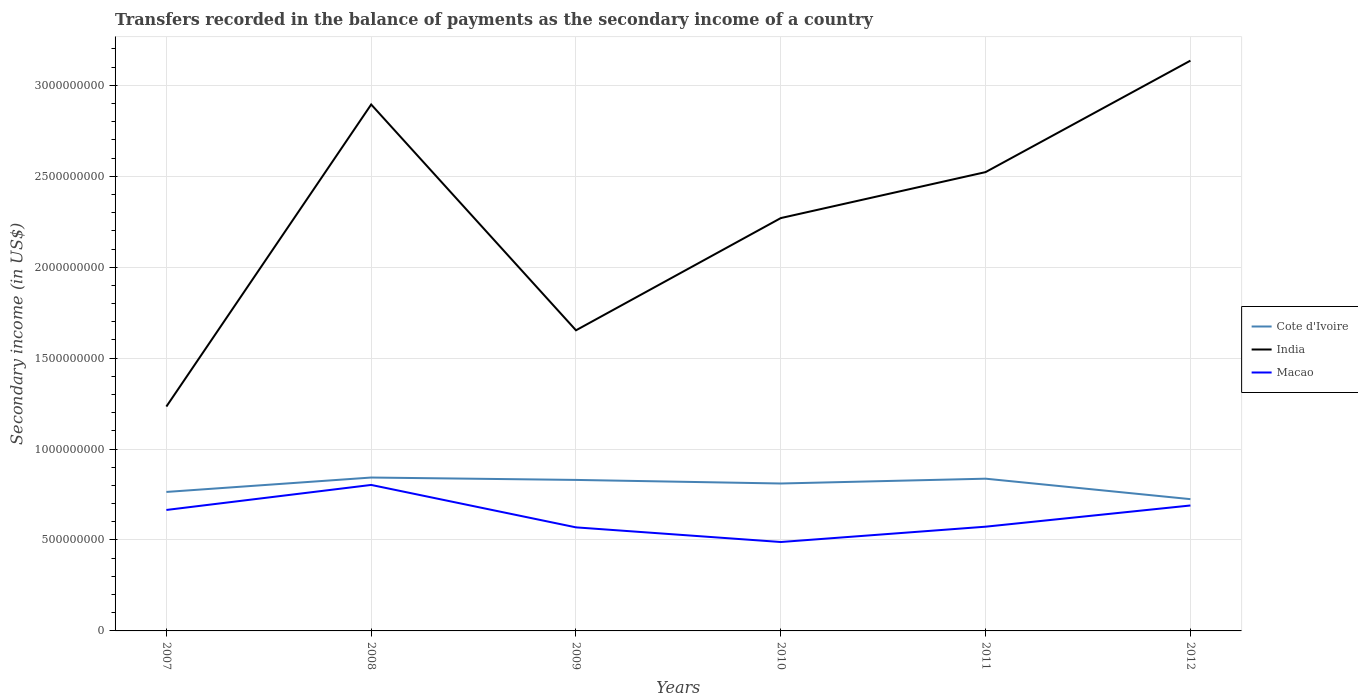Does the line corresponding to Macao intersect with the line corresponding to Cote d'Ivoire?
Provide a succinct answer. No. Is the number of lines equal to the number of legend labels?
Offer a terse response. Yes. Across all years, what is the maximum secondary income of in Cote d'Ivoire?
Your response must be concise. 7.25e+08. In which year was the secondary income of in India maximum?
Your answer should be very brief. 2007. What is the total secondary income of in Macao in the graph?
Provide a short and direct response. 3.14e+08. What is the difference between the highest and the second highest secondary income of in Cote d'Ivoire?
Offer a terse response. 1.19e+08. Is the secondary income of in Cote d'Ivoire strictly greater than the secondary income of in India over the years?
Offer a terse response. Yes. How many lines are there?
Make the answer very short. 3. How many years are there in the graph?
Ensure brevity in your answer.  6. What is the difference between two consecutive major ticks on the Y-axis?
Give a very brief answer. 5.00e+08. Does the graph contain any zero values?
Your answer should be very brief. No. Does the graph contain grids?
Your answer should be compact. Yes. Where does the legend appear in the graph?
Provide a succinct answer. Center right. How many legend labels are there?
Offer a very short reply. 3. How are the legend labels stacked?
Your answer should be very brief. Vertical. What is the title of the graph?
Your answer should be very brief. Transfers recorded in the balance of payments as the secondary income of a country. Does "Spain" appear as one of the legend labels in the graph?
Provide a succinct answer. No. What is the label or title of the Y-axis?
Keep it short and to the point. Secondary income (in US$). What is the Secondary income (in US$) of Cote d'Ivoire in 2007?
Provide a short and direct response. 7.64e+08. What is the Secondary income (in US$) in India in 2007?
Keep it short and to the point. 1.23e+09. What is the Secondary income (in US$) in Macao in 2007?
Make the answer very short. 6.65e+08. What is the Secondary income (in US$) in Cote d'Ivoire in 2008?
Offer a terse response. 8.43e+08. What is the Secondary income (in US$) of India in 2008?
Offer a very short reply. 2.89e+09. What is the Secondary income (in US$) of Macao in 2008?
Offer a very short reply. 8.03e+08. What is the Secondary income (in US$) of Cote d'Ivoire in 2009?
Keep it short and to the point. 8.30e+08. What is the Secondary income (in US$) of India in 2009?
Provide a succinct answer. 1.65e+09. What is the Secondary income (in US$) in Macao in 2009?
Make the answer very short. 5.69e+08. What is the Secondary income (in US$) of Cote d'Ivoire in 2010?
Ensure brevity in your answer.  8.11e+08. What is the Secondary income (in US$) in India in 2010?
Ensure brevity in your answer.  2.27e+09. What is the Secondary income (in US$) of Macao in 2010?
Your answer should be very brief. 4.89e+08. What is the Secondary income (in US$) of Cote d'Ivoire in 2011?
Your response must be concise. 8.37e+08. What is the Secondary income (in US$) in India in 2011?
Keep it short and to the point. 2.52e+09. What is the Secondary income (in US$) in Macao in 2011?
Your answer should be very brief. 5.73e+08. What is the Secondary income (in US$) of Cote d'Ivoire in 2012?
Provide a succinct answer. 7.25e+08. What is the Secondary income (in US$) in India in 2012?
Provide a succinct answer. 3.14e+09. What is the Secondary income (in US$) of Macao in 2012?
Give a very brief answer. 6.90e+08. Across all years, what is the maximum Secondary income (in US$) of Cote d'Ivoire?
Your answer should be very brief. 8.43e+08. Across all years, what is the maximum Secondary income (in US$) in India?
Your answer should be very brief. 3.14e+09. Across all years, what is the maximum Secondary income (in US$) of Macao?
Offer a very short reply. 8.03e+08. Across all years, what is the minimum Secondary income (in US$) of Cote d'Ivoire?
Offer a very short reply. 7.25e+08. Across all years, what is the minimum Secondary income (in US$) of India?
Keep it short and to the point. 1.23e+09. Across all years, what is the minimum Secondary income (in US$) in Macao?
Keep it short and to the point. 4.89e+08. What is the total Secondary income (in US$) of Cote d'Ivoire in the graph?
Your response must be concise. 4.81e+09. What is the total Secondary income (in US$) of India in the graph?
Your answer should be compact. 1.37e+1. What is the total Secondary income (in US$) of Macao in the graph?
Ensure brevity in your answer.  3.79e+09. What is the difference between the Secondary income (in US$) of Cote d'Ivoire in 2007 and that in 2008?
Provide a short and direct response. -7.92e+07. What is the difference between the Secondary income (in US$) in India in 2007 and that in 2008?
Your response must be concise. -1.66e+09. What is the difference between the Secondary income (in US$) in Macao in 2007 and that in 2008?
Your answer should be compact. -1.38e+08. What is the difference between the Secondary income (in US$) in Cote d'Ivoire in 2007 and that in 2009?
Provide a short and direct response. -6.61e+07. What is the difference between the Secondary income (in US$) in India in 2007 and that in 2009?
Give a very brief answer. -4.19e+08. What is the difference between the Secondary income (in US$) of Macao in 2007 and that in 2009?
Ensure brevity in your answer.  9.57e+07. What is the difference between the Secondary income (in US$) in Cote d'Ivoire in 2007 and that in 2010?
Provide a succinct answer. -4.64e+07. What is the difference between the Secondary income (in US$) in India in 2007 and that in 2010?
Offer a terse response. -1.04e+09. What is the difference between the Secondary income (in US$) in Macao in 2007 and that in 2010?
Offer a very short reply. 1.76e+08. What is the difference between the Secondary income (in US$) of Cote d'Ivoire in 2007 and that in 2011?
Make the answer very short. -7.29e+07. What is the difference between the Secondary income (in US$) of India in 2007 and that in 2011?
Offer a terse response. -1.29e+09. What is the difference between the Secondary income (in US$) of Macao in 2007 and that in 2011?
Your response must be concise. 9.20e+07. What is the difference between the Secondary income (in US$) of Cote d'Ivoire in 2007 and that in 2012?
Your response must be concise. 3.96e+07. What is the difference between the Secondary income (in US$) of India in 2007 and that in 2012?
Offer a terse response. -1.90e+09. What is the difference between the Secondary income (in US$) of Macao in 2007 and that in 2012?
Keep it short and to the point. -2.46e+07. What is the difference between the Secondary income (in US$) of Cote d'Ivoire in 2008 and that in 2009?
Provide a short and direct response. 1.31e+07. What is the difference between the Secondary income (in US$) in India in 2008 and that in 2009?
Offer a very short reply. 1.24e+09. What is the difference between the Secondary income (in US$) of Macao in 2008 and that in 2009?
Keep it short and to the point. 2.33e+08. What is the difference between the Secondary income (in US$) of Cote d'Ivoire in 2008 and that in 2010?
Your answer should be very brief. 3.28e+07. What is the difference between the Secondary income (in US$) in India in 2008 and that in 2010?
Your answer should be very brief. 6.25e+08. What is the difference between the Secondary income (in US$) in Macao in 2008 and that in 2010?
Keep it short and to the point. 3.14e+08. What is the difference between the Secondary income (in US$) of Cote d'Ivoire in 2008 and that in 2011?
Offer a terse response. 6.31e+06. What is the difference between the Secondary income (in US$) in India in 2008 and that in 2011?
Provide a short and direct response. 3.72e+08. What is the difference between the Secondary income (in US$) of Macao in 2008 and that in 2011?
Offer a terse response. 2.30e+08. What is the difference between the Secondary income (in US$) of Cote d'Ivoire in 2008 and that in 2012?
Provide a succinct answer. 1.19e+08. What is the difference between the Secondary income (in US$) of India in 2008 and that in 2012?
Keep it short and to the point. -2.41e+08. What is the difference between the Secondary income (in US$) in Macao in 2008 and that in 2012?
Offer a terse response. 1.13e+08. What is the difference between the Secondary income (in US$) of Cote d'Ivoire in 2009 and that in 2010?
Make the answer very short. 1.97e+07. What is the difference between the Secondary income (in US$) of India in 2009 and that in 2010?
Offer a terse response. -6.17e+08. What is the difference between the Secondary income (in US$) in Macao in 2009 and that in 2010?
Give a very brief answer. 8.05e+07. What is the difference between the Secondary income (in US$) in Cote d'Ivoire in 2009 and that in 2011?
Provide a succinct answer. -6.79e+06. What is the difference between the Secondary income (in US$) of India in 2009 and that in 2011?
Offer a terse response. -8.70e+08. What is the difference between the Secondary income (in US$) in Macao in 2009 and that in 2011?
Your answer should be compact. -3.74e+06. What is the difference between the Secondary income (in US$) in Cote d'Ivoire in 2009 and that in 2012?
Offer a terse response. 1.06e+08. What is the difference between the Secondary income (in US$) of India in 2009 and that in 2012?
Make the answer very short. -1.48e+09. What is the difference between the Secondary income (in US$) in Macao in 2009 and that in 2012?
Give a very brief answer. -1.20e+08. What is the difference between the Secondary income (in US$) in Cote d'Ivoire in 2010 and that in 2011?
Ensure brevity in your answer.  -2.65e+07. What is the difference between the Secondary income (in US$) in India in 2010 and that in 2011?
Your answer should be compact. -2.53e+08. What is the difference between the Secondary income (in US$) in Macao in 2010 and that in 2011?
Keep it short and to the point. -8.42e+07. What is the difference between the Secondary income (in US$) in Cote d'Ivoire in 2010 and that in 2012?
Offer a very short reply. 8.60e+07. What is the difference between the Secondary income (in US$) of India in 2010 and that in 2012?
Offer a terse response. -8.66e+08. What is the difference between the Secondary income (in US$) of Macao in 2010 and that in 2012?
Provide a succinct answer. -2.01e+08. What is the difference between the Secondary income (in US$) in Cote d'Ivoire in 2011 and that in 2012?
Offer a terse response. 1.13e+08. What is the difference between the Secondary income (in US$) of India in 2011 and that in 2012?
Offer a terse response. -6.13e+08. What is the difference between the Secondary income (in US$) of Macao in 2011 and that in 2012?
Your answer should be very brief. -1.17e+08. What is the difference between the Secondary income (in US$) of Cote d'Ivoire in 2007 and the Secondary income (in US$) of India in 2008?
Provide a short and direct response. -2.13e+09. What is the difference between the Secondary income (in US$) in Cote d'Ivoire in 2007 and the Secondary income (in US$) in Macao in 2008?
Provide a short and direct response. -3.85e+07. What is the difference between the Secondary income (in US$) of India in 2007 and the Secondary income (in US$) of Macao in 2008?
Provide a succinct answer. 4.31e+08. What is the difference between the Secondary income (in US$) in Cote d'Ivoire in 2007 and the Secondary income (in US$) in India in 2009?
Offer a very short reply. -8.89e+08. What is the difference between the Secondary income (in US$) in Cote d'Ivoire in 2007 and the Secondary income (in US$) in Macao in 2009?
Make the answer very short. 1.95e+08. What is the difference between the Secondary income (in US$) of India in 2007 and the Secondary income (in US$) of Macao in 2009?
Make the answer very short. 6.64e+08. What is the difference between the Secondary income (in US$) of Cote d'Ivoire in 2007 and the Secondary income (in US$) of India in 2010?
Ensure brevity in your answer.  -1.51e+09. What is the difference between the Secondary income (in US$) in Cote d'Ivoire in 2007 and the Secondary income (in US$) in Macao in 2010?
Your response must be concise. 2.75e+08. What is the difference between the Secondary income (in US$) in India in 2007 and the Secondary income (in US$) in Macao in 2010?
Keep it short and to the point. 7.45e+08. What is the difference between the Secondary income (in US$) in Cote d'Ivoire in 2007 and the Secondary income (in US$) in India in 2011?
Give a very brief answer. -1.76e+09. What is the difference between the Secondary income (in US$) in Cote d'Ivoire in 2007 and the Secondary income (in US$) in Macao in 2011?
Ensure brevity in your answer.  1.91e+08. What is the difference between the Secondary income (in US$) of India in 2007 and the Secondary income (in US$) of Macao in 2011?
Your answer should be very brief. 6.61e+08. What is the difference between the Secondary income (in US$) of Cote d'Ivoire in 2007 and the Secondary income (in US$) of India in 2012?
Your response must be concise. -2.37e+09. What is the difference between the Secondary income (in US$) of Cote d'Ivoire in 2007 and the Secondary income (in US$) of Macao in 2012?
Make the answer very short. 7.45e+07. What is the difference between the Secondary income (in US$) of India in 2007 and the Secondary income (in US$) of Macao in 2012?
Your answer should be compact. 5.44e+08. What is the difference between the Secondary income (in US$) in Cote d'Ivoire in 2008 and the Secondary income (in US$) in India in 2009?
Give a very brief answer. -8.10e+08. What is the difference between the Secondary income (in US$) of Cote d'Ivoire in 2008 and the Secondary income (in US$) of Macao in 2009?
Keep it short and to the point. 2.74e+08. What is the difference between the Secondary income (in US$) in India in 2008 and the Secondary income (in US$) in Macao in 2009?
Your answer should be compact. 2.33e+09. What is the difference between the Secondary income (in US$) of Cote d'Ivoire in 2008 and the Secondary income (in US$) of India in 2010?
Give a very brief answer. -1.43e+09. What is the difference between the Secondary income (in US$) of Cote d'Ivoire in 2008 and the Secondary income (in US$) of Macao in 2010?
Your response must be concise. 3.55e+08. What is the difference between the Secondary income (in US$) of India in 2008 and the Secondary income (in US$) of Macao in 2010?
Provide a succinct answer. 2.41e+09. What is the difference between the Secondary income (in US$) in Cote d'Ivoire in 2008 and the Secondary income (in US$) in India in 2011?
Offer a terse response. -1.68e+09. What is the difference between the Secondary income (in US$) of Cote d'Ivoire in 2008 and the Secondary income (in US$) of Macao in 2011?
Your response must be concise. 2.70e+08. What is the difference between the Secondary income (in US$) of India in 2008 and the Secondary income (in US$) of Macao in 2011?
Provide a succinct answer. 2.32e+09. What is the difference between the Secondary income (in US$) of Cote d'Ivoire in 2008 and the Secondary income (in US$) of India in 2012?
Your answer should be very brief. -2.29e+09. What is the difference between the Secondary income (in US$) in Cote d'Ivoire in 2008 and the Secondary income (in US$) in Macao in 2012?
Ensure brevity in your answer.  1.54e+08. What is the difference between the Secondary income (in US$) of India in 2008 and the Secondary income (in US$) of Macao in 2012?
Your response must be concise. 2.20e+09. What is the difference between the Secondary income (in US$) of Cote d'Ivoire in 2009 and the Secondary income (in US$) of India in 2010?
Your response must be concise. -1.44e+09. What is the difference between the Secondary income (in US$) of Cote d'Ivoire in 2009 and the Secondary income (in US$) of Macao in 2010?
Your answer should be compact. 3.41e+08. What is the difference between the Secondary income (in US$) of India in 2009 and the Secondary income (in US$) of Macao in 2010?
Your response must be concise. 1.16e+09. What is the difference between the Secondary income (in US$) in Cote d'Ivoire in 2009 and the Secondary income (in US$) in India in 2011?
Your answer should be very brief. -1.69e+09. What is the difference between the Secondary income (in US$) of Cote d'Ivoire in 2009 and the Secondary income (in US$) of Macao in 2011?
Your answer should be very brief. 2.57e+08. What is the difference between the Secondary income (in US$) of India in 2009 and the Secondary income (in US$) of Macao in 2011?
Offer a very short reply. 1.08e+09. What is the difference between the Secondary income (in US$) in Cote d'Ivoire in 2009 and the Secondary income (in US$) in India in 2012?
Your answer should be compact. -2.31e+09. What is the difference between the Secondary income (in US$) in Cote d'Ivoire in 2009 and the Secondary income (in US$) in Macao in 2012?
Your answer should be compact. 1.41e+08. What is the difference between the Secondary income (in US$) of India in 2009 and the Secondary income (in US$) of Macao in 2012?
Your response must be concise. 9.63e+08. What is the difference between the Secondary income (in US$) of Cote d'Ivoire in 2010 and the Secondary income (in US$) of India in 2011?
Make the answer very short. -1.71e+09. What is the difference between the Secondary income (in US$) of Cote d'Ivoire in 2010 and the Secondary income (in US$) of Macao in 2011?
Provide a succinct answer. 2.37e+08. What is the difference between the Secondary income (in US$) in India in 2010 and the Secondary income (in US$) in Macao in 2011?
Your response must be concise. 1.70e+09. What is the difference between the Secondary income (in US$) in Cote d'Ivoire in 2010 and the Secondary income (in US$) in India in 2012?
Provide a short and direct response. -2.33e+09. What is the difference between the Secondary income (in US$) of Cote d'Ivoire in 2010 and the Secondary income (in US$) of Macao in 2012?
Make the answer very short. 1.21e+08. What is the difference between the Secondary income (in US$) in India in 2010 and the Secondary income (in US$) in Macao in 2012?
Keep it short and to the point. 1.58e+09. What is the difference between the Secondary income (in US$) in Cote d'Ivoire in 2011 and the Secondary income (in US$) in India in 2012?
Make the answer very short. -2.30e+09. What is the difference between the Secondary income (in US$) of Cote d'Ivoire in 2011 and the Secondary income (in US$) of Macao in 2012?
Keep it short and to the point. 1.47e+08. What is the difference between the Secondary income (in US$) of India in 2011 and the Secondary income (in US$) of Macao in 2012?
Make the answer very short. 1.83e+09. What is the average Secondary income (in US$) of Cote d'Ivoire per year?
Keep it short and to the point. 8.02e+08. What is the average Secondary income (in US$) of India per year?
Your answer should be very brief. 2.29e+09. What is the average Secondary income (in US$) of Macao per year?
Make the answer very short. 6.31e+08. In the year 2007, what is the difference between the Secondary income (in US$) in Cote d'Ivoire and Secondary income (in US$) in India?
Keep it short and to the point. -4.70e+08. In the year 2007, what is the difference between the Secondary income (in US$) of Cote d'Ivoire and Secondary income (in US$) of Macao?
Keep it short and to the point. 9.91e+07. In the year 2007, what is the difference between the Secondary income (in US$) of India and Secondary income (in US$) of Macao?
Make the answer very short. 5.69e+08. In the year 2008, what is the difference between the Secondary income (in US$) of Cote d'Ivoire and Secondary income (in US$) of India?
Make the answer very short. -2.05e+09. In the year 2008, what is the difference between the Secondary income (in US$) of Cote d'Ivoire and Secondary income (in US$) of Macao?
Your answer should be very brief. 4.07e+07. In the year 2008, what is the difference between the Secondary income (in US$) of India and Secondary income (in US$) of Macao?
Give a very brief answer. 2.09e+09. In the year 2009, what is the difference between the Secondary income (in US$) of Cote d'Ivoire and Secondary income (in US$) of India?
Offer a terse response. -8.23e+08. In the year 2009, what is the difference between the Secondary income (in US$) in Cote d'Ivoire and Secondary income (in US$) in Macao?
Keep it short and to the point. 2.61e+08. In the year 2009, what is the difference between the Secondary income (in US$) in India and Secondary income (in US$) in Macao?
Give a very brief answer. 1.08e+09. In the year 2010, what is the difference between the Secondary income (in US$) in Cote d'Ivoire and Secondary income (in US$) in India?
Your answer should be very brief. -1.46e+09. In the year 2010, what is the difference between the Secondary income (in US$) in Cote d'Ivoire and Secondary income (in US$) in Macao?
Your response must be concise. 3.22e+08. In the year 2010, what is the difference between the Secondary income (in US$) in India and Secondary income (in US$) in Macao?
Provide a succinct answer. 1.78e+09. In the year 2011, what is the difference between the Secondary income (in US$) of Cote d'Ivoire and Secondary income (in US$) of India?
Offer a terse response. -1.69e+09. In the year 2011, what is the difference between the Secondary income (in US$) of Cote d'Ivoire and Secondary income (in US$) of Macao?
Offer a terse response. 2.64e+08. In the year 2011, what is the difference between the Secondary income (in US$) of India and Secondary income (in US$) of Macao?
Offer a very short reply. 1.95e+09. In the year 2012, what is the difference between the Secondary income (in US$) of Cote d'Ivoire and Secondary income (in US$) of India?
Provide a short and direct response. -2.41e+09. In the year 2012, what is the difference between the Secondary income (in US$) of Cote d'Ivoire and Secondary income (in US$) of Macao?
Your answer should be compact. 3.48e+07. In the year 2012, what is the difference between the Secondary income (in US$) of India and Secondary income (in US$) of Macao?
Your answer should be very brief. 2.45e+09. What is the ratio of the Secondary income (in US$) in Cote d'Ivoire in 2007 to that in 2008?
Offer a terse response. 0.91. What is the ratio of the Secondary income (in US$) of India in 2007 to that in 2008?
Your response must be concise. 0.43. What is the ratio of the Secondary income (in US$) in Macao in 2007 to that in 2008?
Your answer should be very brief. 0.83. What is the ratio of the Secondary income (in US$) of Cote d'Ivoire in 2007 to that in 2009?
Your answer should be compact. 0.92. What is the ratio of the Secondary income (in US$) of India in 2007 to that in 2009?
Your answer should be very brief. 0.75. What is the ratio of the Secondary income (in US$) in Macao in 2007 to that in 2009?
Offer a terse response. 1.17. What is the ratio of the Secondary income (in US$) in Cote d'Ivoire in 2007 to that in 2010?
Keep it short and to the point. 0.94. What is the ratio of the Secondary income (in US$) of India in 2007 to that in 2010?
Ensure brevity in your answer.  0.54. What is the ratio of the Secondary income (in US$) in Macao in 2007 to that in 2010?
Keep it short and to the point. 1.36. What is the ratio of the Secondary income (in US$) in Cote d'Ivoire in 2007 to that in 2011?
Provide a succinct answer. 0.91. What is the ratio of the Secondary income (in US$) in India in 2007 to that in 2011?
Your answer should be compact. 0.49. What is the ratio of the Secondary income (in US$) in Macao in 2007 to that in 2011?
Offer a terse response. 1.16. What is the ratio of the Secondary income (in US$) of Cote d'Ivoire in 2007 to that in 2012?
Ensure brevity in your answer.  1.05. What is the ratio of the Secondary income (in US$) of India in 2007 to that in 2012?
Ensure brevity in your answer.  0.39. What is the ratio of the Secondary income (in US$) in Cote d'Ivoire in 2008 to that in 2009?
Offer a very short reply. 1.02. What is the ratio of the Secondary income (in US$) of India in 2008 to that in 2009?
Your answer should be compact. 1.75. What is the ratio of the Secondary income (in US$) of Macao in 2008 to that in 2009?
Your response must be concise. 1.41. What is the ratio of the Secondary income (in US$) of Cote d'Ivoire in 2008 to that in 2010?
Keep it short and to the point. 1.04. What is the ratio of the Secondary income (in US$) of India in 2008 to that in 2010?
Provide a short and direct response. 1.28. What is the ratio of the Secondary income (in US$) of Macao in 2008 to that in 2010?
Offer a terse response. 1.64. What is the ratio of the Secondary income (in US$) of Cote d'Ivoire in 2008 to that in 2011?
Give a very brief answer. 1.01. What is the ratio of the Secondary income (in US$) of India in 2008 to that in 2011?
Offer a terse response. 1.15. What is the ratio of the Secondary income (in US$) of Macao in 2008 to that in 2011?
Ensure brevity in your answer.  1.4. What is the ratio of the Secondary income (in US$) of Cote d'Ivoire in 2008 to that in 2012?
Your answer should be very brief. 1.16. What is the ratio of the Secondary income (in US$) of India in 2008 to that in 2012?
Offer a very short reply. 0.92. What is the ratio of the Secondary income (in US$) of Macao in 2008 to that in 2012?
Give a very brief answer. 1.16. What is the ratio of the Secondary income (in US$) of Cote d'Ivoire in 2009 to that in 2010?
Offer a terse response. 1.02. What is the ratio of the Secondary income (in US$) in India in 2009 to that in 2010?
Your response must be concise. 0.73. What is the ratio of the Secondary income (in US$) in Macao in 2009 to that in 2010?
Keep it short and to the point. 1.16. What is the ratio of the Secondary income (in US$) in India in 2009 to that in 2011?
Your answer should be compact. 0.66. What is the ratio of the Secondary income (in US$) of Macao in 2009 to that in 2011?
Your answer should be very brief. 0.99. What is the ratio of the Secondary income (in US$) of Cote d'Ivoire in 2009 to that in 2012?
Offer a very short reply. 1.15. What is the ratio of the Secondary income (in US$) in India in 2009 to that in 2012?
Keep it short and to the point. 0.53. What is the ratio of the Secondary income (in US$) in Macao in 2009 to that in 2012?
Make the answer very short. 0.83. What is the ratio of the Secondary income (in US$) in Cote d'Ivoire in 2010 to that in 2011?
Offer a terse response. 0.97. What is the ratio of the Secondary income (in US$) in India in 2010 to that in 2011?
Keep it short and to the point. 0.9. What is the ratio of the Secondary income (in US$) in Macao in 2010 to that in 2011?
Your response must be concise. 0.85. What is the ratio of the Secondary income (in US$) in Cote d'Ivoire in 2010 to that in 2012?
Ensure brevity in your answer.  1.12. What is the ratio of the Secondary income (in US$) in India in 2010 to that in 2012?
Keep it short and to the point. 0.72. What is the ratio of the Secondary income (in US$) in Macao in 2010 to that in 2012?
Keep it short and to the point. 0.71. What is the ratio of the Secondary income (in US$) of Cote d'Ivoire in 2011 to that in 2012?
Provide a short and direct response. 1.16. What is the ratio of the Secondary income (in US$) in India in 2011 to that in 2012?
Provide a short and direct response. 0.8. What is the ratio of the Secondary income (in US$) of Macao in 2011 to that in 2012?
Offer a terse response. 0.83. What is the difference between the highest and the second highest Secondary income (in US$) in Cote d'Ivoire?
Provide a short and direct response. 6.31e+06. What is the difference between the highest and the second highest Secondary income (in US$) in India?
Make the answer very short. 2.41e+08. What is the difference between the highest and the second highest Secondary income (in US$) of Macao?
Make the answer very short. 1.13e+08. What is the difference between the highest and the lowest Secondary income (in US$) in Cote d'Ivoire?
Ensure brevity in your answer.  1.19e+08. What is the difference between the highest and the lowest Secondary income (in US$) of India?
Offer a terse response. 1.90e+09. What is the difference between the highest and the lowest Secondary income (in US$) of Macao?
Keep it short and to the point. 3.14e+08. 